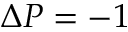<formula> <loc_0><loc_0><loc_500><loc_500>\Delta P = - 1</formula> 